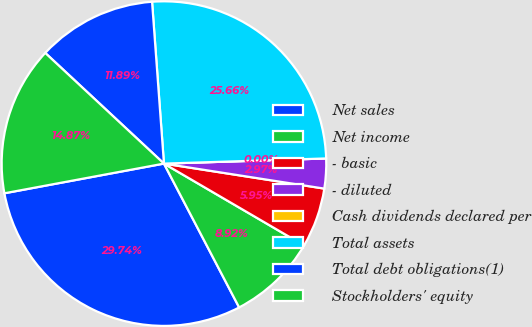Convert chart. <chart><loc_0><loc_0><loc_500><loc_500><pie_chart><fcel>Net sales<fcel>Net income<fcel>- basic<fcel>- diluted<fcel>Cash dividends declared per<fcel>Total assets<fcel>Total debt obligations(1)<fcel>Stockholders' equity<nl><fcel>29.74%<fcel>8.92%<fcel>5.95%<fcel>2.97%<fcel>0.0%<fcel>25.66%<fcel>11.89%<fcel>14.87%<nl></chart> 